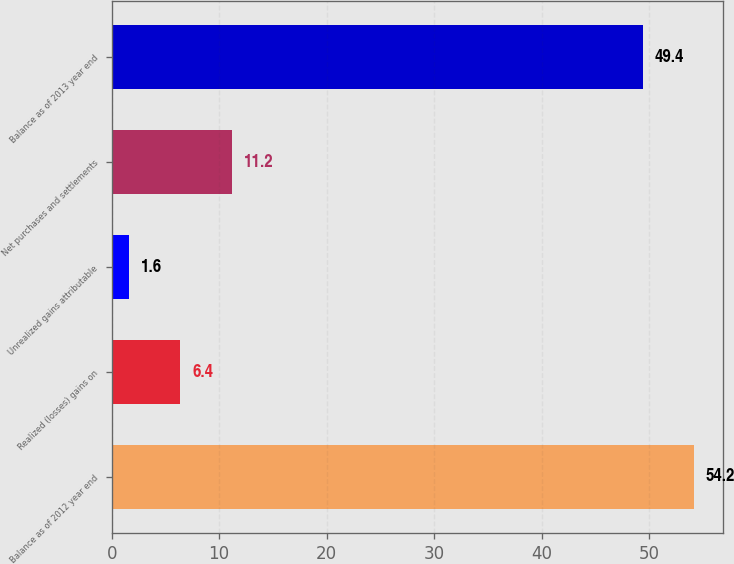Convert chart to OTSL. <chart><loc_0><loc_0><loc_500><loc_500><bar_chart><fcel>Balance as of 2012 year end<fcel>Realized (losses) gains on<fcel>Unrealized gains attributable<fcel>Net purchases and settlements<fcel>Balance as of 2013 year end<nl><fcel>54.2<fcel>6.4<fcel>1.6<fcel>11.2<fcel>49.4<nl></chart> 